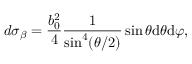Convert formula to latex. <formula><loc_0><loc_0><loc_500><loc_500>d { \sigma _ { \beta } } = \frac { b _ { 0 } ^ { 2 } } { 4 } \frac { 1 } { { { \sin } ^ { 4 } } ( \theta / 2 ) } \sin \theta d \theta d \varphi ,</formula> 